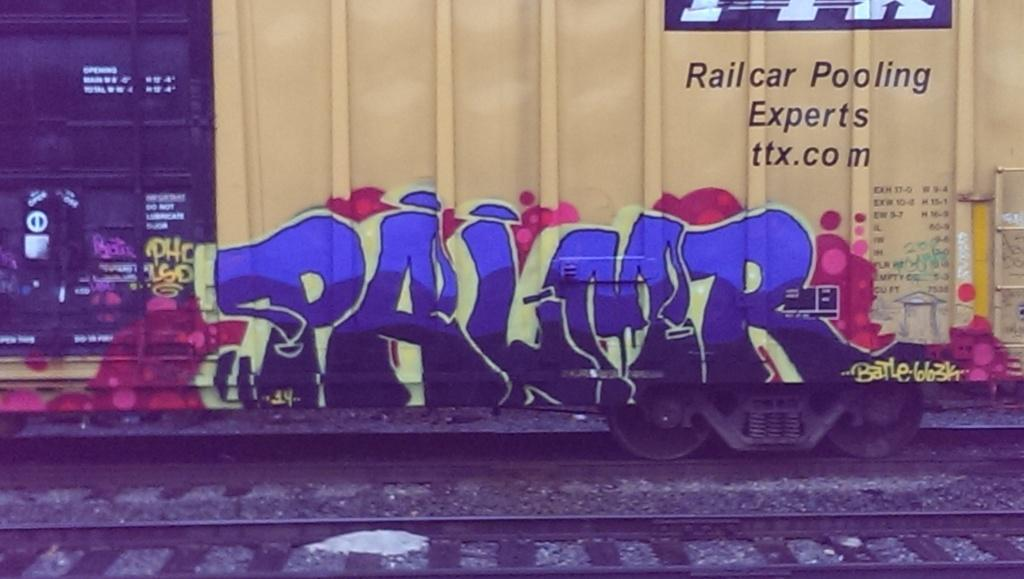<image>
Write a terse but informative summary of the picture. A yellow train car that says Railcar Pooling Experts on the side along with grafitti. 